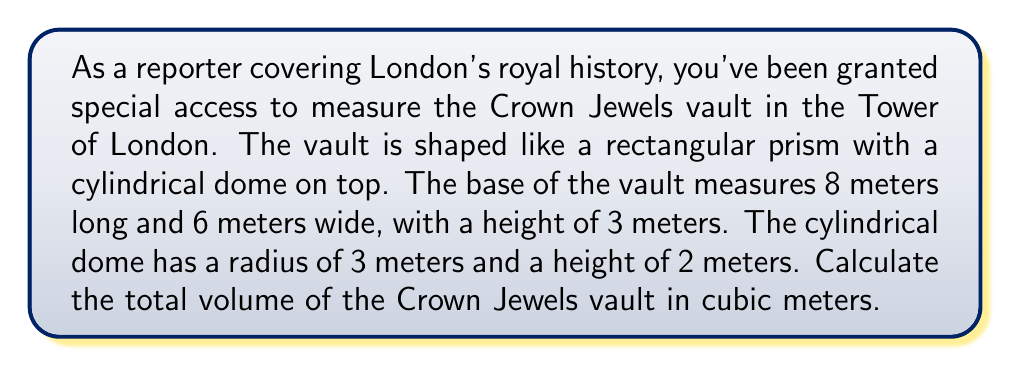Can you solve this math problem? To calculate the total volume of the Crown Jewels vault, we need to sum the volumes of the rectangular prism base and the cylindrical dome.

1. Volume of the rectangular prism base:
   $$V_{prism} = l \times w \times h$$
   $$V_{prism} = 8 \text{ m} \times 6 \text{ m} \times 3 \text{ m} = 144 \text{ m}^3$$

2. Volume of the cylindrical dome:
   $$V_{cylinder} = \pi r^2 h$$
   $$V_{cylinder} = \pi \times (3 \text{ m})^2 \times 2 \text{ m} = 18\pi \text{ m}^3$$

3. Total volume:
   $$V_{total} = V_{prism} + V_{cylinder}$$
   $$V_{total} = 144 \text{ m}^3 + 18\pi \text{ m}^3$$
   $$V_{total} = 144 + 18\pi \text{ m}^3$$
   $$V_{total} \approx 200.57 \text{ m}^3$$

[asy]
import three;

size(200);
currentprojection=perspective(6,3,2);

// Rectangular prism
draw(box((0,0,0),(8,6,3)));

// Cylindrical dome
path3 p=circle((4,3,3),3);
draw(surface(p--cycle),lightblue+opacity(0.5));
draw(shift(0,0,2)*surface(p--cycle),lightblue+opacity(0.5));
draw(surface(p--shift(0,0,2)*p),lightblue+opacity(0.5));

// Labels
label("8 m",(4,6.5,0));
label("6 m",(8.5,3,0));
label("3 m",(8.5,0,1.5));
label("2 m",(8.5,0,4));
label("r = 3 m",(4,0,3.5));
[/asy]
Answer: $200.57 \text{ m}^3$ 